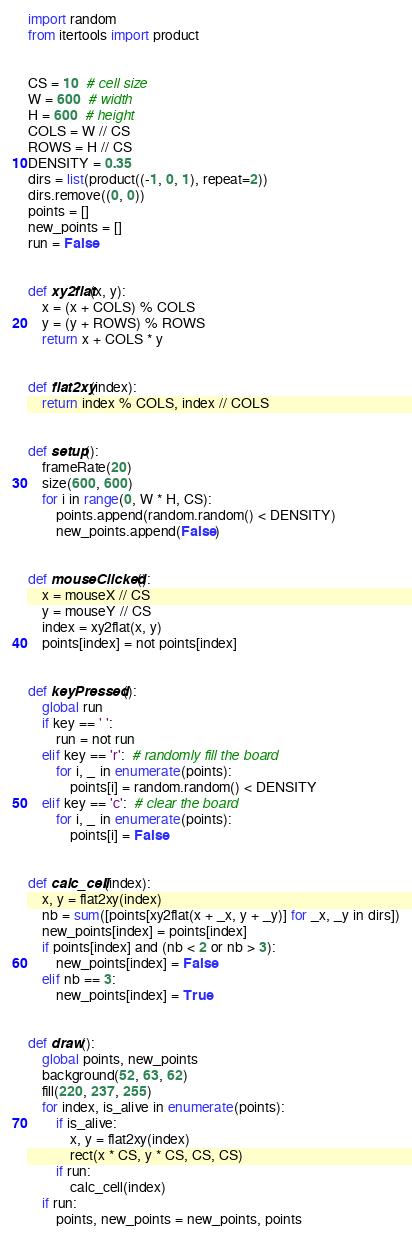<code> <loc_0><loc_0><loc_500><loc_500><_Python_>import random
from itertools import product


CS = 10  # cell size
W = 600  # width
H = 600  # height
COLS = W // CS
ROWS = H // CS
DENSITY = 0.35
dirs = list(product((-1, 0, 1), repeat=2))
dirs.remove((0, 0))
points = []
new_points = []
run = False


def xy2flat(x, y):
    x = (x + COLS) % COLS
    y = (y + ROWS) % ROWS
    return x + COLS * y


def flat2xy(index):
    return index % COLS, index // COLS


def setup():
    frameRate(20)
    size(600, 600)
    for i in range(0, W * H, CS):
        points.append(random.random() < DENSITY)
        new_points.append(False)


def mouseClicked():
    x = mouseX // CS
    y = mouseY // CS
    index = xy2flat(x, y)
    points[index] = not points[index]


def keyPressed():
    global run
    if key == ' ':
        run = not run
    elif key == 'r':  # randomly fill the board
        for i, _ in enumerate(points):
            points[i] = random.random() < DENSITY
    elif key == 'c':  # clear the board
        for i, _ in enumerate(points):
            points[i] = False


def calc_cell(index):
    x, y = flat2xy(index)
    nb = sum([points[xy2flat(x + _x, y + _y)] for _x, _y in dirs])
    new_points[index] = points[index]
    if points[index] and (nb < 2 or nb > 3):
        new_points[index] = False
    elif nb == 3:
        new_points[index] = True


def draw():
    global points, new_points
    background(52, 63, 62)
    fill(220, 237, 255)
    for index, is_alive in enumerate(points):
        if is_alive:
            x, y = flat2xy(index)
            rect(x * CS, y * CS, CS, CS)
        if run:
            calc_cell(index)
    if run:
        points, new_points = new_points, points
</code> 